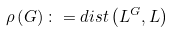<formula> <loc_0><loc_0><loc_500><loc_500>\rho \left ( G \right ) \colon = d i s t \left ( L ^ { G } , L \right )</formula> 